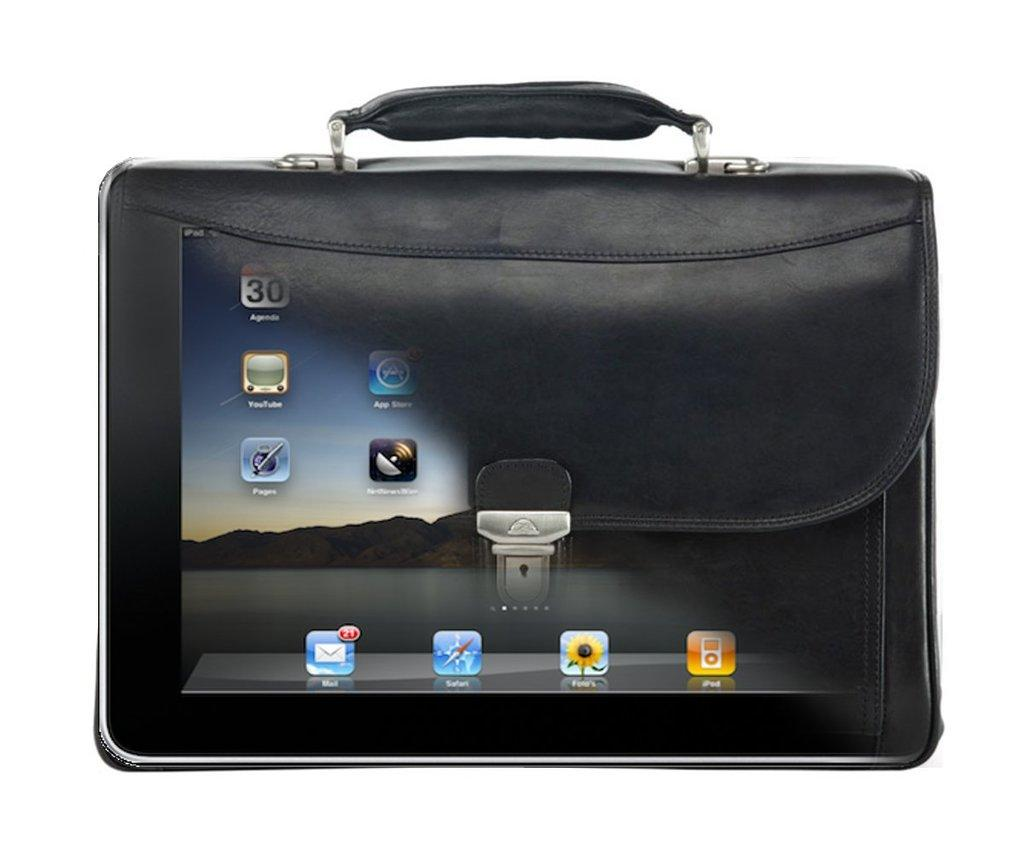What object can be seen in the image? There is a bag in the image. What type of cloth is used to cover the heat in the image? There is no cloth or heat present in the image; it only features a bag. 